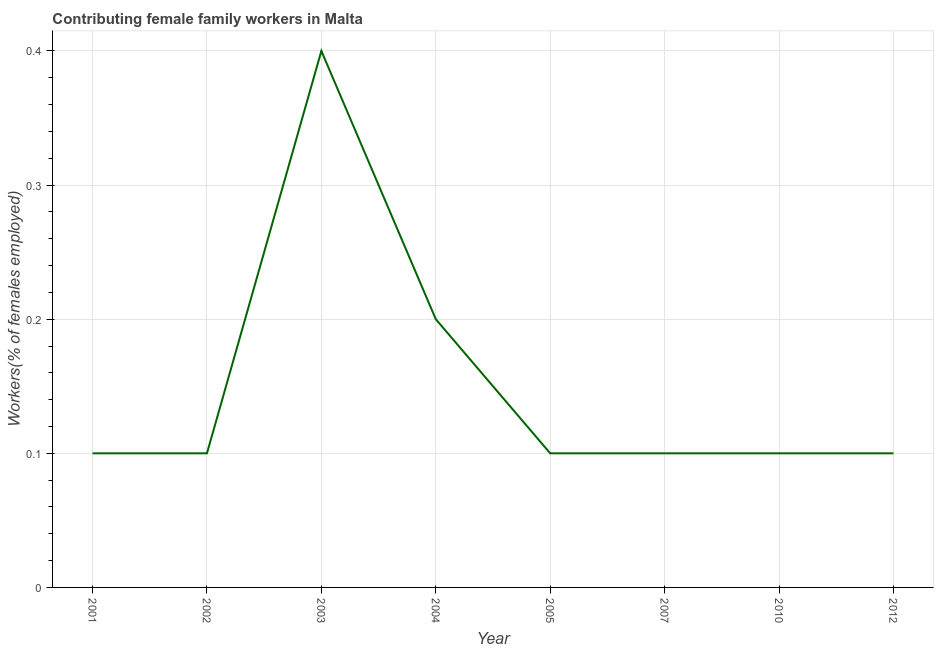What is the contributing female family workers in 2012?
Your answer should be compact. 0.1. Across all years, what is the maximum contributing female family workers?
Your answer should be compact. 0.4. Across all years, what is the minimum contributing female family workers?
Make the answer very short. 0.1. In which year was the contributing female family workers maximum?
Your answer should be compact. 2003. What is the sum of the contributing female family workers?
Ensure brevity in your answer.  1.2. What is the difference between the contributing female family workers in 2001 and 2012?
Provide a short and direct response. 0. What is the average contributing female family workers per year?
Make the answer very short. 0.15. What is the median contributing female family workers?
Offer a very short reply. 0.1. In how many years, is the contributing female family workers greater than 0.2 %?
Provide a succinct answer. 2. Do a majority of the years between 2003 and 2002 (inclusive) have contributing female family workers greater than 0.26 %?
Offer a very short reply. No. What is the ratio of the contributing female family workers in 2002 to that in 2004?
Your response must be concise. 0.5. Is the contributing female family workers in 2002 less than that in 2010?
Give a very brief answer. No. What is the difference between the highest and the second highest contributing female family workers?
Your answer should be very brief. 0.2. Is the sum of the contributing female family workers in 2003 and 2010 greater than the maximum contributing female family workers across all years?
Offer a very short reply. Yes. What is the difference between the highest and the lowest contributing female family workers?
Provide a succinct answer. 0.3. In how many years, is the contributing female family workers greater than the average contributing female family workers taken over all years?
Your response must be concise. 2. Does the contributing female family workers monotonically increase over the years?
Give a very brief answer. No. How many lines are there?
Your answer should be very brief. 1. How many years are there in the graph?
Your answer should be very brief. 8. What is the title of the graph?
Offer a very short reply. Contributing female family workers in Malta. What is the label or title of the X-axis?
Provide a short and direct response. Year. What is the label or title of the Y-axis?
Your answer should be very brief. Workers(% of females employed). What is the Workers(% of females employed) of 2001?
Your answer should be compact. 0.1. What is the Workers(% of females employed) of 2002?
Your answer should be compact. 0.1. What is the Workers(% of females employed) of 2003?
Your answer should be compact. 0.4. What is the Workers(% of females employed) of 2004?
Provide a short and direct response. 0.2. What is the Workers(% of females employed) in 2005?
Offer a terse response. 0.1. What is the Workers(% of females employed) in 2007?
Offer a very short reply. 0.1. What is the Workers(% of females employed) in 2010?
Make the answer very short. 0.1. What is the Workers(% of females employed) in 2012?
Your response must be concise. 0.1. What is the difference between the Workers(% of females employed) in 2001 and 2003?
Provide a succinct answer. -0.3. What is the difference between the Workers(% of females employed) in 2001 and 2010?
Provide a short and direct response. 0. What is the difference between the Workers(% of females employed) in 2002 and 2003?
Keep it short and to the point. -0.3. What is the difference between the Workers(% of females employed) in 2002 and 2004?
Your response must be concise. -0.1. What is the difference between the Workers(% of females employed) in 2002 and 2007?
Your answer should be very brief. 0. What is the difference between the Workers(% of females employed) in 2003 and 2010?
Provide a short and direct response. 0.3. What is the difference between the Workers(% of females employed) in 2004 and 2007?
Provide a short and direct response. 0.1. What is the difference between the Workers(% of females employed) in 2004 and 2012?
Keep it short and to the point. 0.1. What is the difference between the Workers(% of females employed) in 2007 and 2012?
Offer a terse response. 0. What is the difference between the Workers(% of females employed) in 2010 and 2012?
Make the answer very short. 0. What is the ratio of the Workers(% of females employed) in 2001 to that in 2002?
Provide a succinct answer. 1. What is the ratio of the Workers(% of females employed) in 2001 to that in 2004?
Give a very brief answer. 0.5. What is the ratio of the Workers(% of females employed) in 2001 to that in 2005?
Your answer should be compact. 1. What is the ratio of the Workers(% of females employed) in 2001 to that in 2010?
Give a very brief answer. 1. What is the ratio of the Workers(% of females employed) in 2002 to that in 2004?
Offer a very short reply. 0.5. What is the ratio of the Workers(% of females employed) in 2002 to that in 2005?
Your answer should be very brief. 1. What is the ratio of the Workers(% of females employed) in 2002 to that in 2010?
Your answer should be very brief. 1. What is the ratio of the Workers(% of females employed) in 2002 to that in 2012?
Give a very brief answer. 1. What is the ratio of the Workers(% of females employed) in 2003 to that in 2010?
Your answer should be compact. 4. What is the ratio of the Workers(% of females employed) in 2003 to that in 2012?
Keep it short and to the point. 4. What is the ratio of the Workers(% of females employed) in 2004 to that in 2007?
Your response must be concise. 2. What is the ratio of the Workers(% of females employed) in 2005 to that in 2007?
Offer a terse response. 1. What is the ratio of the Workers(% of females employed) in 2005 to that in 2010?
Ensure brevity in your answer.  1. What is the ratio of the Workers(% of females employed) in 2010 to that in 2012?
Provide a succinct answer. 1. 